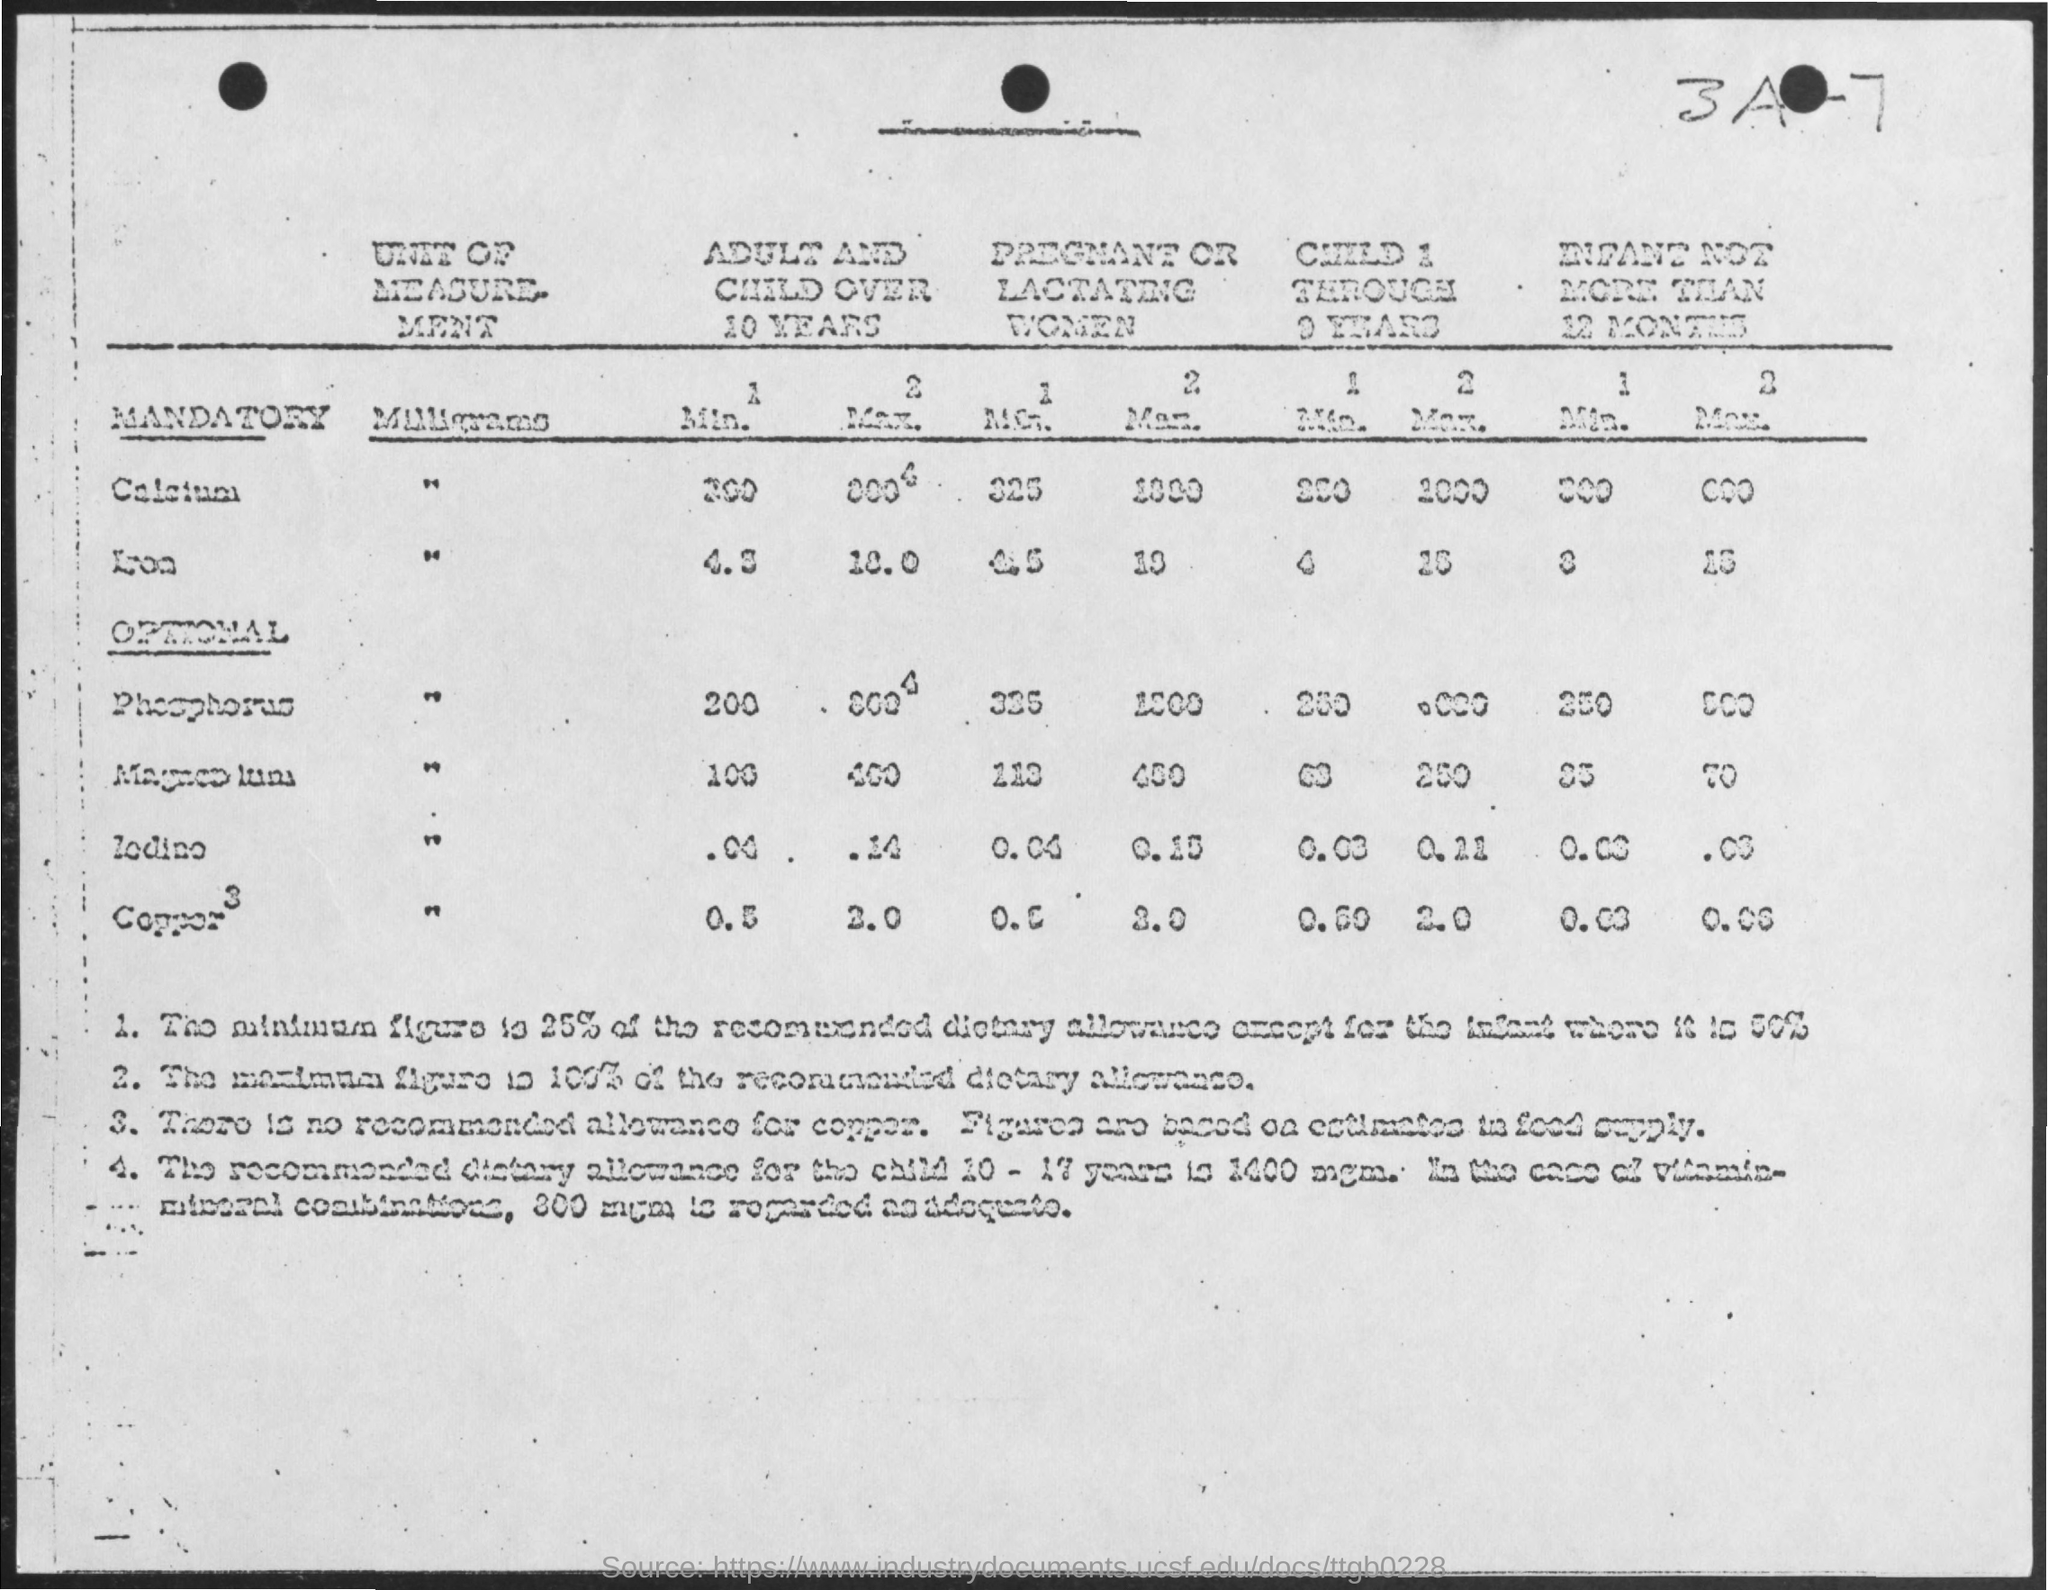What is written in the top right?
Provide a short and direct response. 3a-7. 